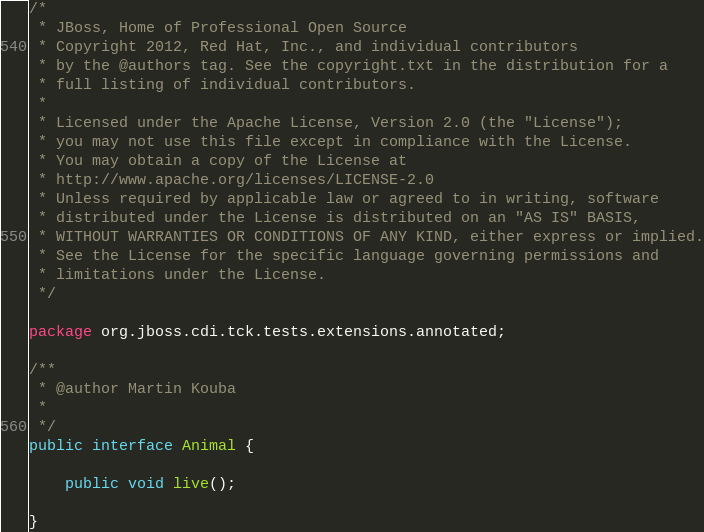<code> <loc_0><loc_0><loc_500><loc_500><_Java_>/*
 * JBoss, Home of Professional Open Source
 * Copyright 2012, Red Hat, Inc., and individual contributors
 * by the @authors tag. See the copyright.txt in the distribution for a
 * full listing of individual contributors.
 *
 * Licensed under the Apache License, Version 2.0 (the "License");
 * you may not use this file except in compliance with the License.
 * You may obtain a copy of the License at
 * http://www.apache.org/licenses/LICENSE-2.0
 * Unless required by applicable law or agreed to in writing, software
 * distributed under the License is distributed on an "AS IS" BASIS,
 * WITHOUT WARRANTIES OR CONDITIONS OF ANY KIND, either express or implied.
 * See the License for the specific language governing permissions and
 * limitations under the License.
 */

package org.jboss.cdi.tck.tests.extensions.annotated;

/**
 * @author Martin Kouba
 * 
 */
public interface Animal {

    public void live();

}
</code> 